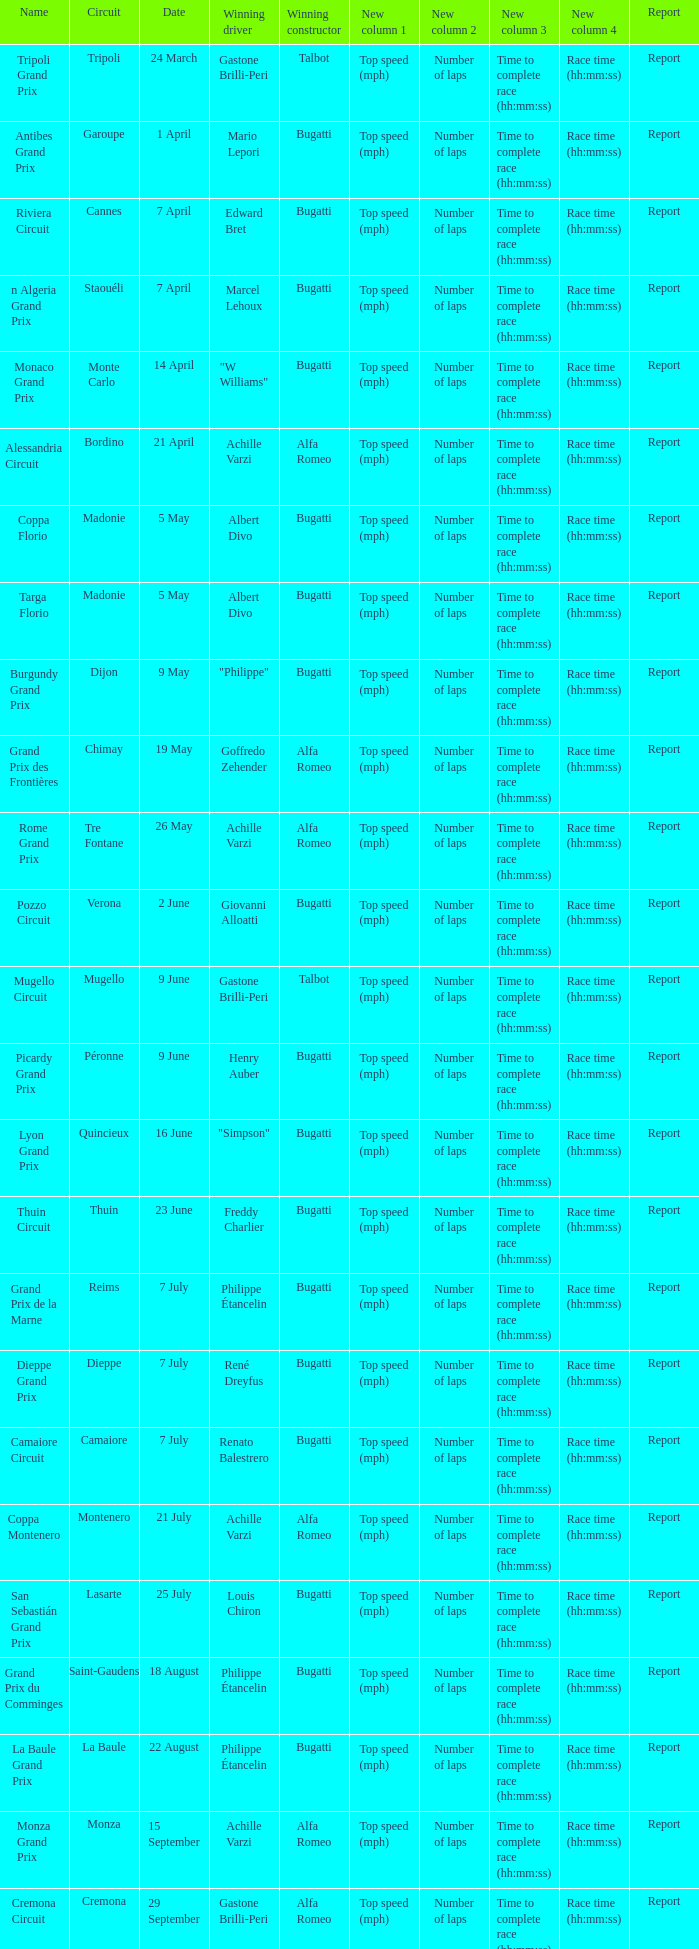What Name has a Winning constructor of bugatti, and a Winning driver of louis chiron? San Sebastián Grand Prix. 